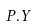Convert formula to latex. <formula><loc_0><loc_0><loc_500><loc_500>P . Y</formula> 